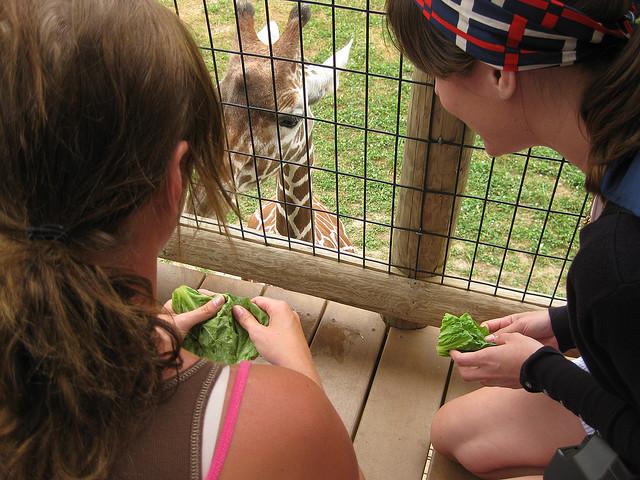Is this animal hungry?
Short answer required. Yes. Are these people excited to see the animal?
Quick response, please. Yes. Are they feeding the giraffe?
Concise answer only. Yes. 